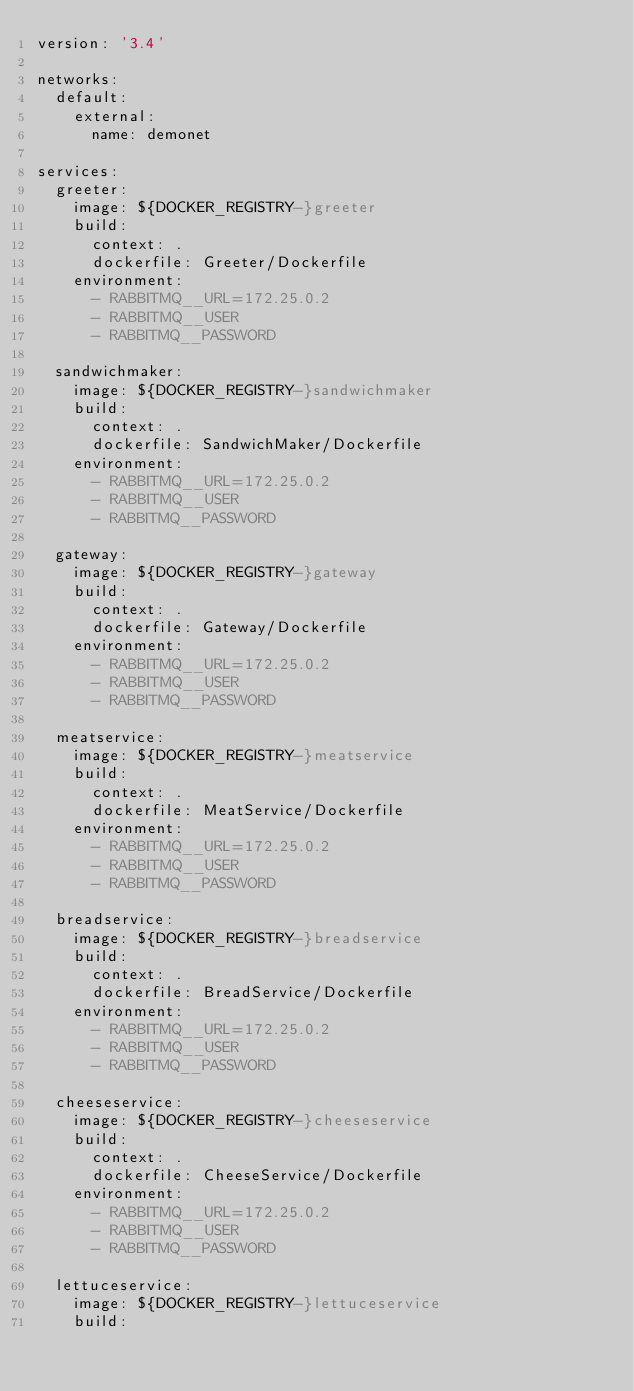<code> <loc_0><loc_0><loc_500><loc_500><_YAML_>version: '3.4'

networks:
  default:
    external:
      name: demonet

services:
  greeter:
    image: ${DOCKER_REGISTRY-}greeter
    build:
      context: .
      dockerfile: Greeter/Dockerfile
    environment: 
      - RABBITMQ__URL=172.25.0.2
      - RABBITMQ__USER
      - RABBITMQ__PASSWORD

  sandwichmaker:
    image: ${DOCKER_REGISTRY-}sandwichmaker
    build:
      context: .
      dockerfile: SandwichMaker/Dockerfile
    environment: 
      - RABBITMQ__URL=172.25.0.2
      - RABBITMQ__USER
      - RABBITMQ__PASSWORD

  gateway:
    image: ${DOCKER_REGISTRY-}gateway
    build:
      context: .
      dockerfile: Gateway/Dockerfile
    environment: 
      - RABBITMQ__URL=172.25.0.2
      - RABBITMQ__USER
      - RABBITMQ__PASSWORD

  meatservice:
    image: ${DOCKER_REGISTRY-}meatservice
    build:
      context: .
      dockerfile: MeatService/Dockerfile
    environment: 
      - RABBITMQ__URL=172.25.0.2
      - RABBITMQ__USER
      - RABBITMQ__PASSWORD

  breadservice:
    image: ${DOCKER_REGISTRY-}breadservice
    build:
      context: .
      dockerfile: BreadService/Dockerfile
    environment: 
      - RABBITMQ__URL=172.25.0.2
      - RABBITMQ__USER
      - RABBITMQ__PASSWORD

  cheeseservice:
    image: ${DOCKER_REGISTRY-}cheeseservice
    build:
      context: .
      dockerfile: CheeseService/Dockerfile
    environment: 
      - RABBITMQ__URL=172.25.0.2
      - RABBITMQ__USER
      - RABBITMQ__PASSWORD

  lettuceservice:
    image: ${DOCKER_REGISTRY-}lettuceservice
    build:</code> 